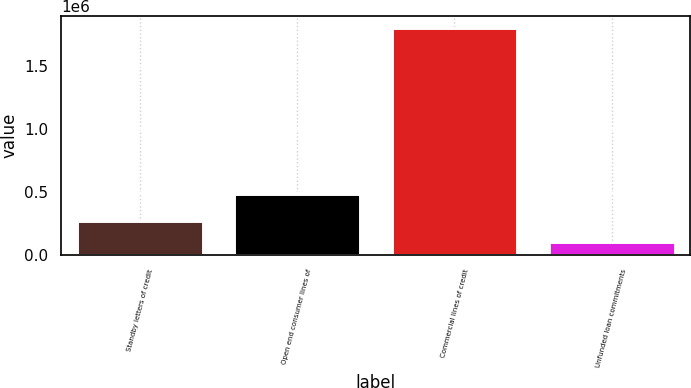<chart> <loc_0><loc_0><loc_500><loc_500><bar_chart><fcel>Standby letters of credit<fcel>Open end consumer lines of<fcel>Commercial lines of credit<fcel>Unfunded loan commitments<nl><fcel>271446<fcel>480304<fcel>1.80477e+06<fcel>101077<nl></chart> 